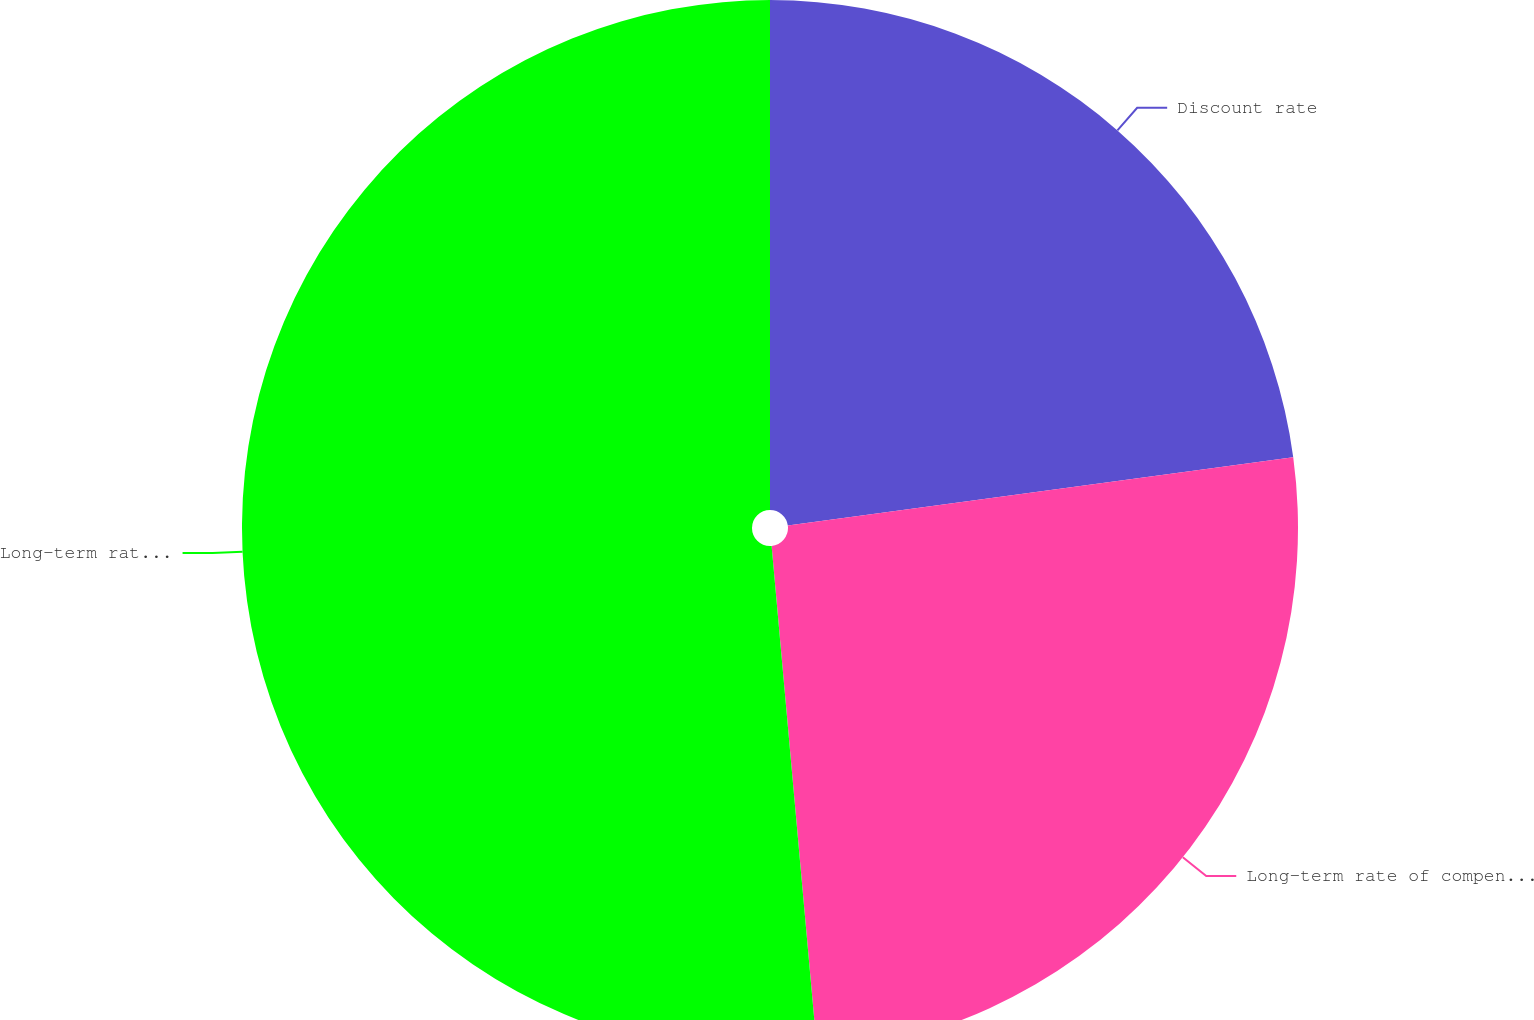Convert chart. <chart><loc_0><loc_0><loc_500><loc_500><pie_chart><fcel>Discount rate<fcel>Long-term rate of compensation<fcel>Long-term rate of return on<nl><fcel>22.86%<fcel>25.71%<fcel>51.43%<nl></chart> 